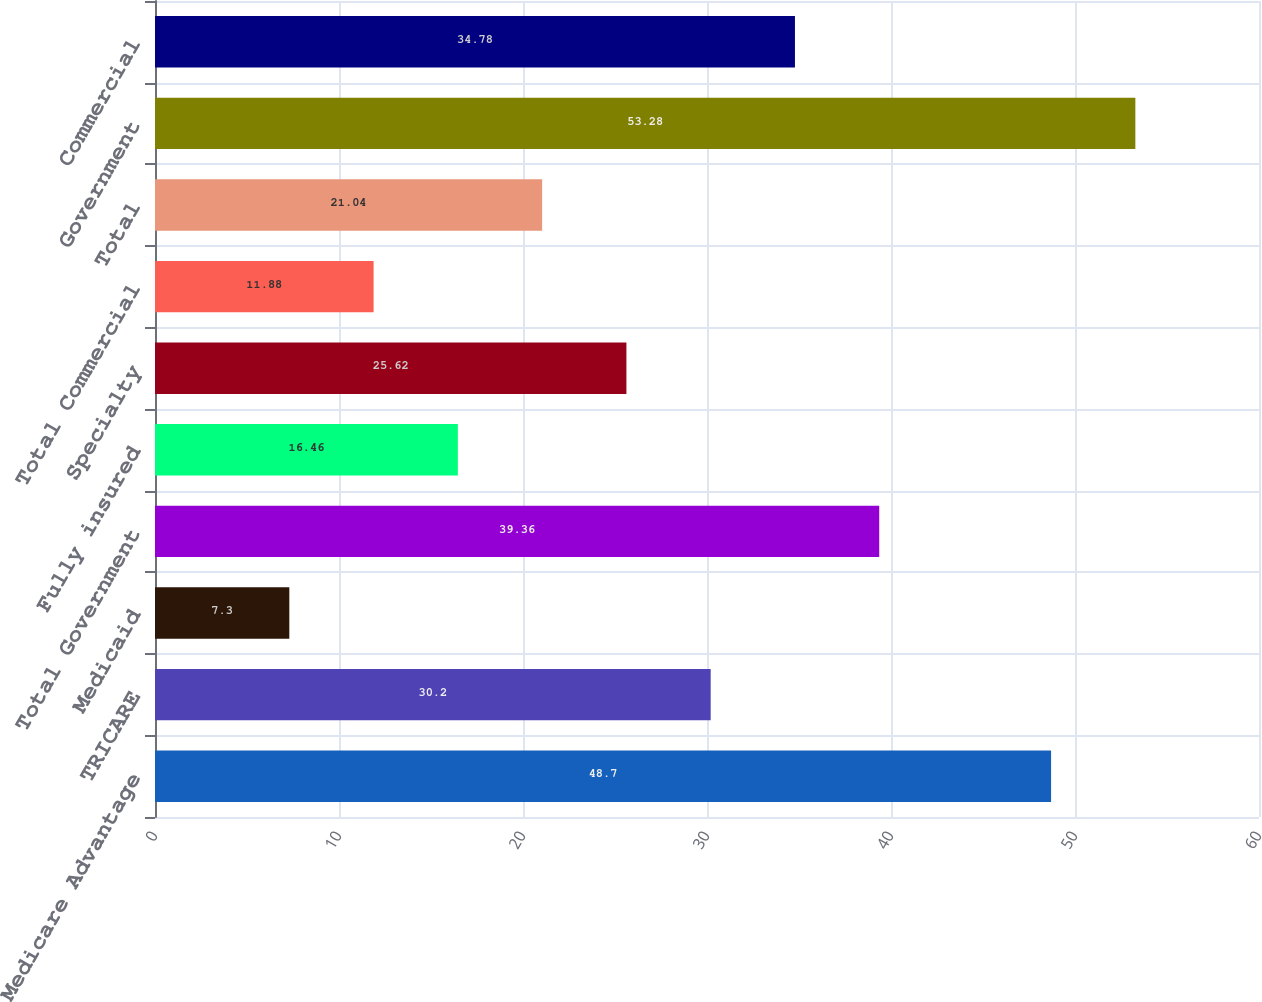Convert chart. <chart><loc_0><loc_0><loc_500><loc_500><bar_chart><fcel>Medicare Advantage<fcel>TRICARE<fcel>Medicaid<fcel>Total Government<fcel>Fully insured<fcel>Specialty<fcel>Total Commercial<fcel>Total<fcel>Government<fcel>Commercial<nl><fcel>48.7<fcel>30.2<fcel>7.3<fcel>39.36<fcel>16.46<fcel>25.62<fcel>11.88<fcel>21.04<fcel>53.28<fcel>34.78<nl></chart> 